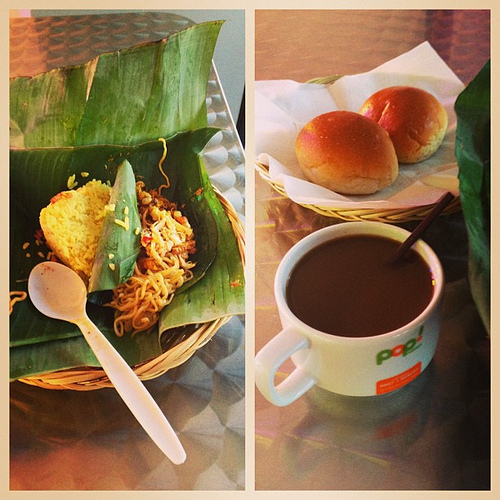What are the noodles in? Capturing the essence of comfort food, the noodles are beautifully plated in a bamboo basket lined with a fresh banana leaf. 